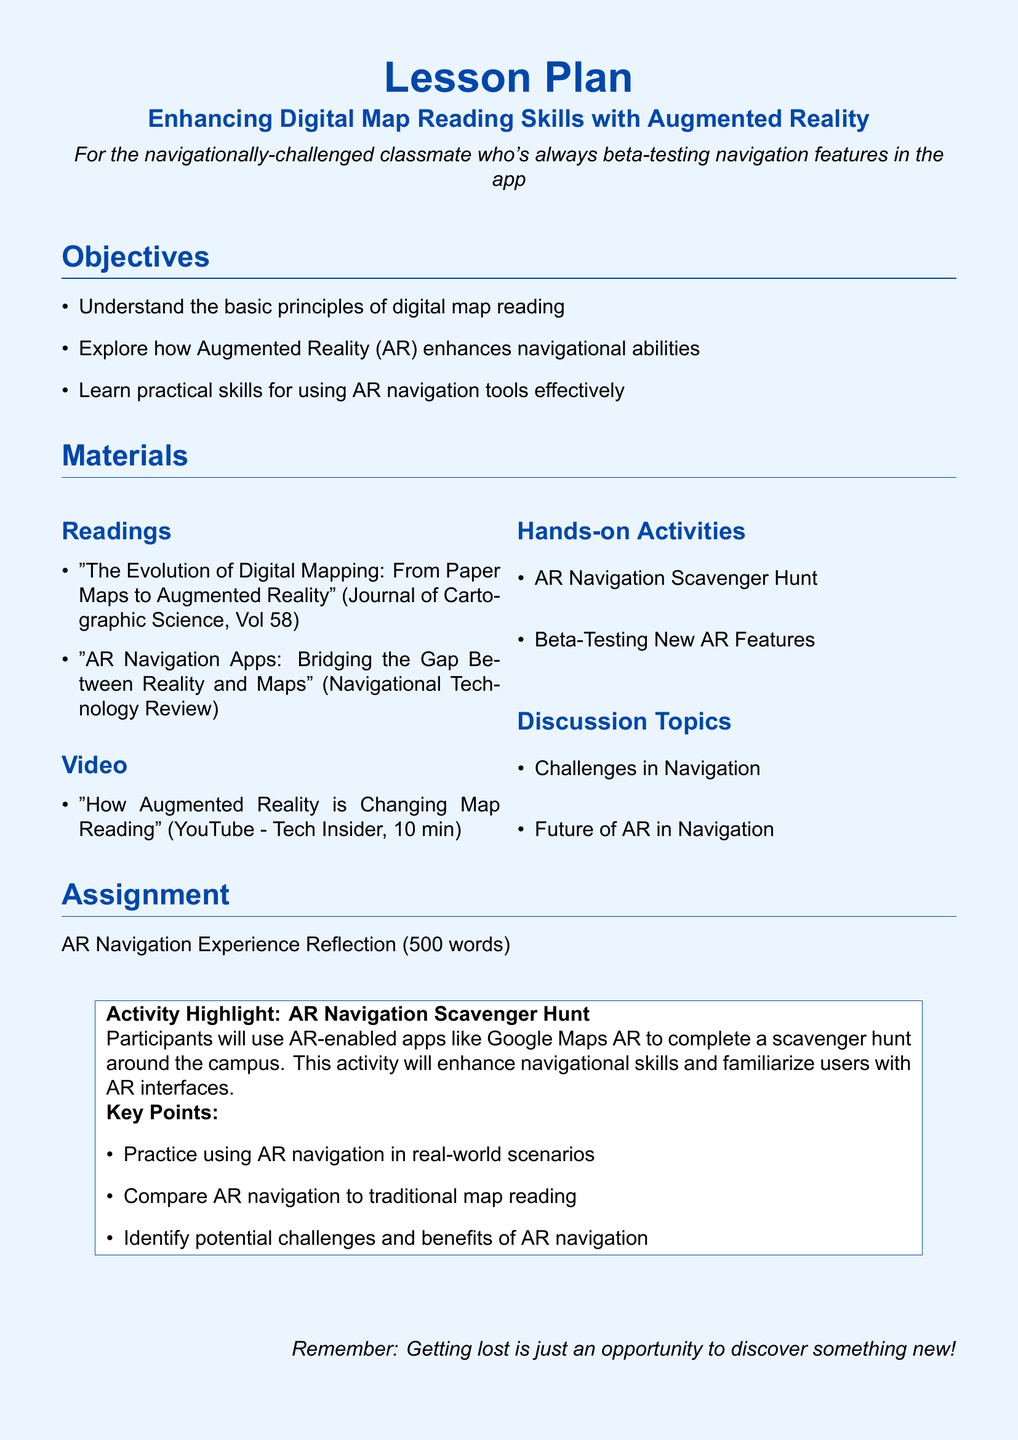What is the title of the lesson plan? The title is provided at the beginning of the document, outlining the focus of the lesson.
Answer: Enhancing Digital Map Reading Skills with Augmented Reality How many objectives are listed in the lesson plan? The number of objectives can be counted in the Objectives section of the document.
Answer: 3 What is one of the hands-on activities mentioned? The document outlines various activities under the Materials section.
Answer: AR Navigation Scavenger Hunt What type of video is included in the materials? The type of video is specified in the Video subsection of the Materials section.
Answer: YouTube What is the word count required for the assignment reflection? The assignment section specifies the required length for the reflection task.
Answer: 500 words Which publication discusses the evolution of digital mapping? One of the readings is designated to this topic in the Readings subsection of the Materials section.
Answer: Journal of Cartographic Science What is a key point of the AR Navigation Scavenger Hunt activity? Key points are noted in the activity highlight section of the lesson plan.
Answer: Practice using AR navigation in real-world scenarios What is the color of the page background? The page color is set in the document's settings.
Answer: light blue 